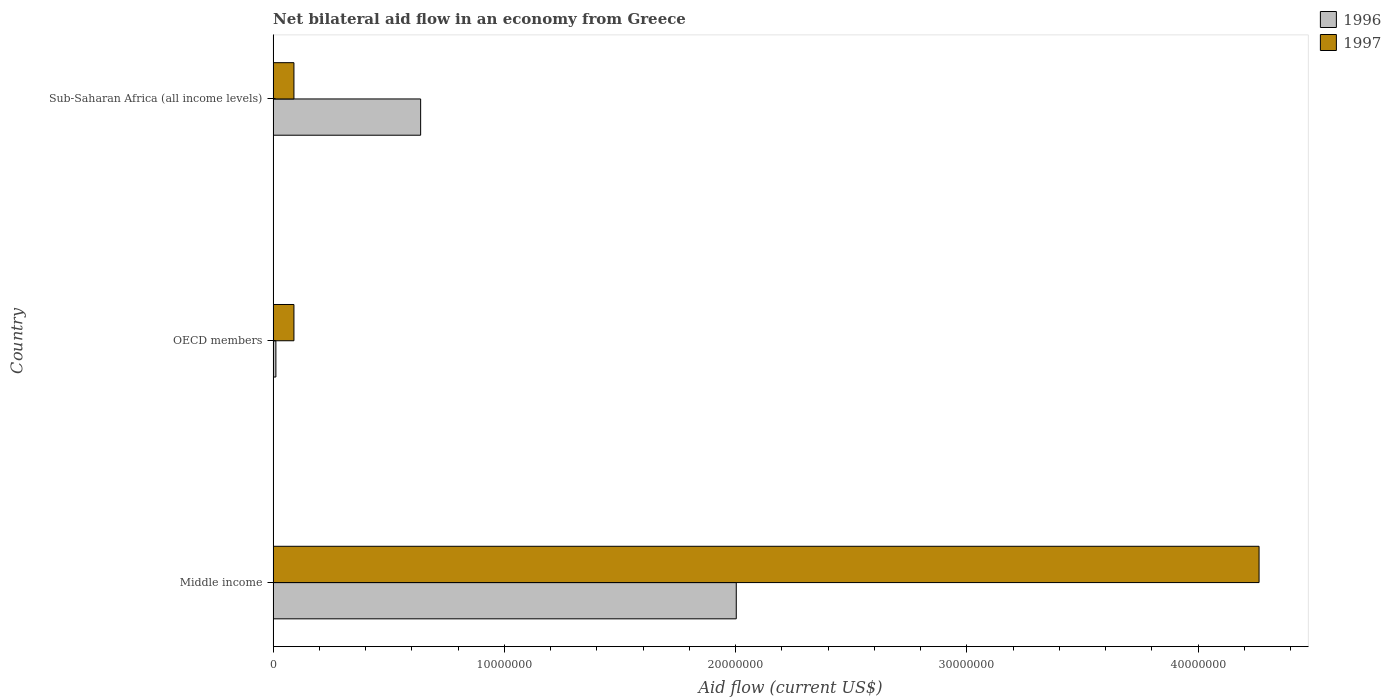How many groups of bars are there?
Your response must be concise. 3. How many bars are there on the 1st tick from the top?
Provide a succinct answer. 2. How many bars are there on the 2nd tick from the bottom?
Your response must be concise. 2. What is the label of the 1st group of bars from the top?
Your answer should be compact. Sub-Saharan Africa (all income levels). What is the net bilateral aid flow in 1996 in Sub-Saharan Africa (all income levels)?
Keep it short and to the point. 6.38e+06. Across all countries, what is the maximum net bilateral aid flow in 1997?
Offer a very short reply. 4.26e+07. In which country was the net bilateral aid flow in 1996 maximum?
Your response must be concise. Middle income. In which country was the net bilateral aid flow in 1996 minimum?
Keep it short and to the point. OECD members. What is the total net bilateral aid flow in 1997 in the graph?
Keep it short and to the point. 4.44e+07. What is the difference between the net bilateral aid flow in 1996 in Middle income and that in Sub-Saharan Africa (all income levels)?
Your answer should be very brief. 1.36e+07. What is the difference between the net bilateral aid flow in 1997 in Sub-Saharan Africa (all income levels) and the net bilateral aid flow in 1996 in Middle income?
Offer a very short reply. -1.91e+07. What is the average net bilateral aid flow in 1997 per country?
Make the answer very short. 1.48e+07. What is the difference between the net bilateral aid flow in 1996 and net bilateral aid flow in 1997 in Sub-Saharan Africa (all income levels)?
Provide a succinct answer. 5.48e+06. What is the ratio of the net bilateral aid flow in 1996 in Middle income to that in Sub-Saharan Africa (all income levels)?
Provide a short and direct response. 3.14. Is the net bilateral aid flow in 1997 in Middle income less than that in OECD members?
Give a very brief answer. No. Is the difference between the net bilateral aid flow in 1996 in Middle income and OECD members greater than the difference between the net bilateral aid flow in 1997 in Middle income and OECD members?
Keep it short and to the point. No. What is the difference between the highest and the second highest net bilateral aid flow in 1996?
Provide a succinct answer. 1.36e+07. What is the difference between the highest and the lowest net bilateral aid flow in 1996?
Make the answer very short. 1.99e+07. In how many countries, is the net bilateral aid flow in 1997 greater than the average net bilateral aid flow in 1997 taken over all countries?
Keep it short and to the point. 1. What does the 1st bar from the top in OECD members represents?
Provide a short and direct response. 1997. What does the 1st bar from the bottom in Sub-Saharan Africa (all income levels) represents?
Provide a short and direct response. 1996. How many bars are there?
Ensure brevity in your answer.  6. What is the difference between two consecutive major ticks on the X-axis?
Make the answer very short. 1.00e+07. Are the values on the major ticks of X-axis written in scientific E-notation?
Your answer should be compact. No. Does the graph contain any zero values?
Ensure brevity in your answer.  No. Does the graph contain grids?
Your answer should be compact. No. How many legend labels are there?
Your answer should be very brief. 2. How are the legend labels stacked?
Ensure brevity in your answer.  Vertical. What is the title of the graph?
Provide a succinct answer. Net bilateral aid flow in an economy from Greece. What is the label or title of the X-axis?
Make the answer very short. Aid flow (current US$). What is the label or title of the Y-axis?
Ensure brevity in your answer.  Country. What is the Aid flow (current US$) of 1996 in Middle income?
Keep it short and to the point. 2.00e+07. What is the Aid flow (current US$) of 1997 in Middle income?
Provide a succinct answer. 4.26e+07. What is the Aid flow (current US$) of 1996 in OECD members?
Your answer should be very brief. 1.20e+05. What is the Aid flow (current US$) of 1997 in OECD members?
Provide a succinct answer. 9.00e+05. What is the Aid flow (current US$) in 1996 in Sub-Saharan Africa (all income levels)?
Your answer should be compact. 6.38e+06. What is the Aid flow (current US$) in 1997 in Sub-Saharan Africa (all income levels)?
Ensure brevity in your answer.  9.00e+05. Across all countries, what is the maximum Aid flow (current US$) of 1996?
Give a very brief answer. 2.00e+07. Across all countries, what is the maximum Aid flow (current US$) in 1997?
Your response must be concise. 4.26e+07. What is the total Aid flow (current US$) of 1996 in the graph?
Provide a short and direct response. 2.65e+07. What is the total Aid flow (current US$) in 1997 in the graph?
Offer a terse response. 4.44e+07. What is the difference between the Aid flow (current US$) in 1996 in Middle income and that in OECD members?
Offer a terse response. 1.99e+07. What is the difference between the Aid flow (current US$) in 1997 in Middle income and that in OECD members?
Your answer should be very brief. 4.17e+07. What is the difference between the Aid flow (current US$) in 1996 in Middle income and that in Sub-Saharan Africa (all income levels)?
Provide a short and direct response. 1.36e+07. What is the difference between the Aid flow (current US$) in 1997 in Middle income and that in Sub-Saharan Africa (all income levels)?
Keep it short and to the point. 4.17e+07. What is the difference between the Aid flow (current US$) of 1996 in OECD members and that in Sub-Saharan Africa (all income levels)?
Offer a very short reply. -6.26e+06. What is the difference between the Aid flow (current US$) in 1996 in Middle income and the Aid flow (current US$) in 1997 in OECD members?
Offer a very short reply. 1.91e+07. What is the difference between the Aid flow (current US$) of 1996 in Middle income and the Aid flow (current US$) of 1997 in Sub-Saharan Africa (all income levels)?
Ensure brevity in your answer.  1.91e+07. What is the difference between the Aid flow (current US$) of 1996 in OECD members and the Aid flow (current US$) of 1997 in Sub-Saharan Africa (all income levels)?
Your response must be concise. -7.80e+05. What is the average Aid flow (current US$) of 1996 per country?
Provide a succinct answer. 8.84e+06. What is the average Aid flow (current US$) of 1997 per country?
Provide a succinct answer. 1.48e+07. What is the difference between the Aid flow (current US$) of 1996 and Aid flow (current US$) of 1997 in Middle income?
Provide a short and direct response. -2.26e+07. What is the difference between the Aid flow (current US$) in 1996 and Aid flow (current US$) in 1997 in OECD members?
Your answer should be compact. -7.80e+05. What is the difference between the Aid flow (current US$) of 1996 and Aid flow (current US$) of 1997 in Sub-Saharan Africa (all income levels)?
Your answer should be compact. 5.48e+06. What is the ratio of the Aid flow (current US$) of 1996 in Middle income to that in OECD members?
Your response must be concise. 166.92. What is the ratio of the Aid flow (current US$) in 1997 in Middle income to that in OECD members?
Your response must be concise. 47.38. What is the ratio of the Aid flow (current US$) of 1996 in Middle income to that in Sub-Saharan Africa (all income levels)?
Provide a short and direct response. 3.14. What is the ratio of the Aid flow (current US$) in 1997 in Middle income to that in Sub-Saharan Africa (all income levels)?
Your answer should be very brief. 47.38. What is the ratio of the Aid flow (current US$) in 1996 in OECD members to that in Sub-Saharan Africa (all income levels)?
Offer a terse response. 0.02. What is the difference between the highest and the second highest Aid flow (current US$) in 1996?
Your response must be concise. 1.36e+07. What is the difference between the highest and the second highest Aid flow (current US$) in 1997?
Provide a short and direct response. 4.17e+07. What is the difference between the highest and the lowest Aid flow (current US$) in 1996?
Your answer should be compact. 1.99e+07. What is the difference between the highest and the lowest Aid flow (current US$) of 1997?
Provide a short and direct response. 4.17e+07. 